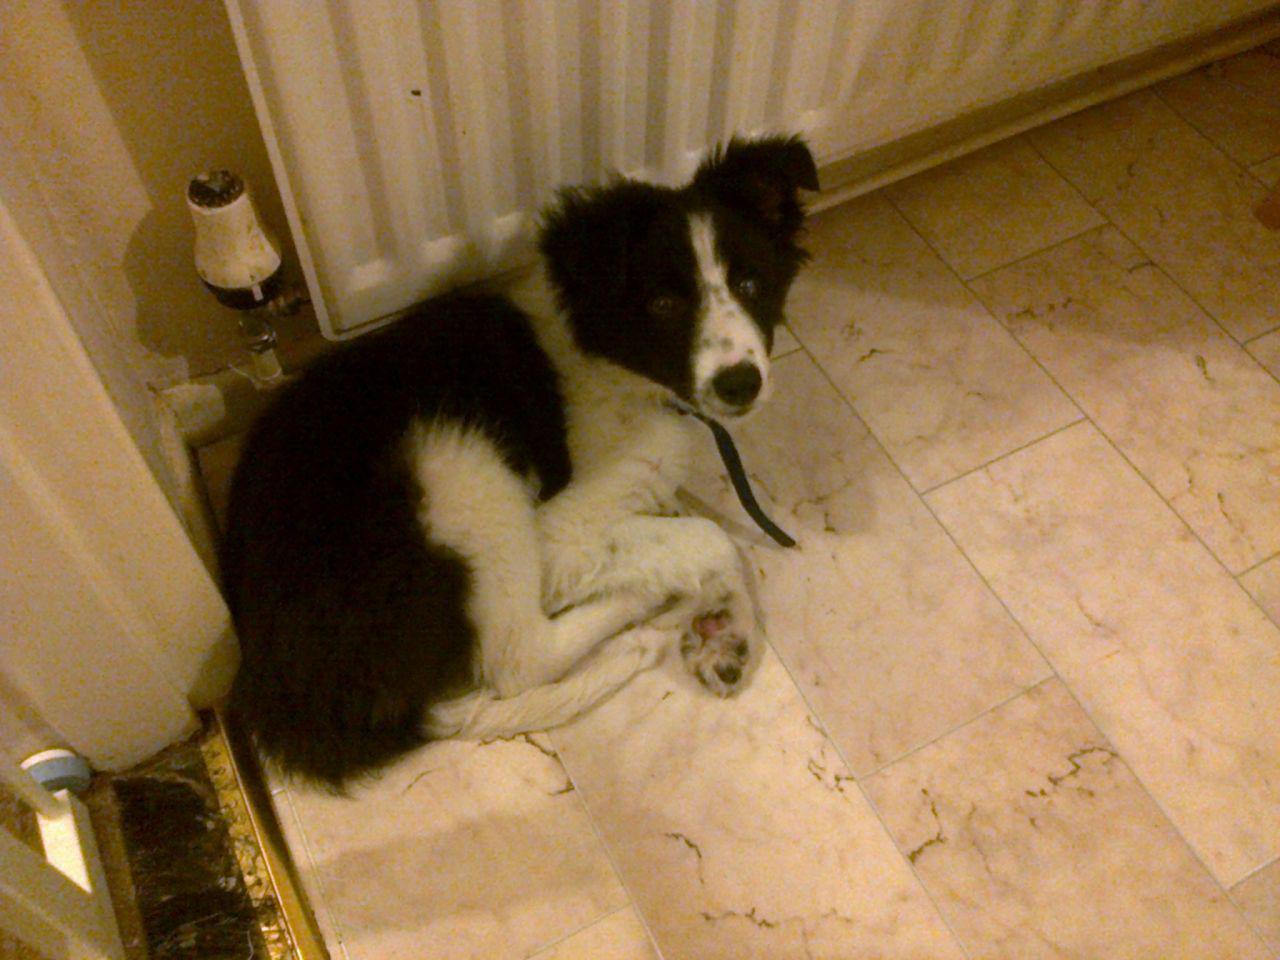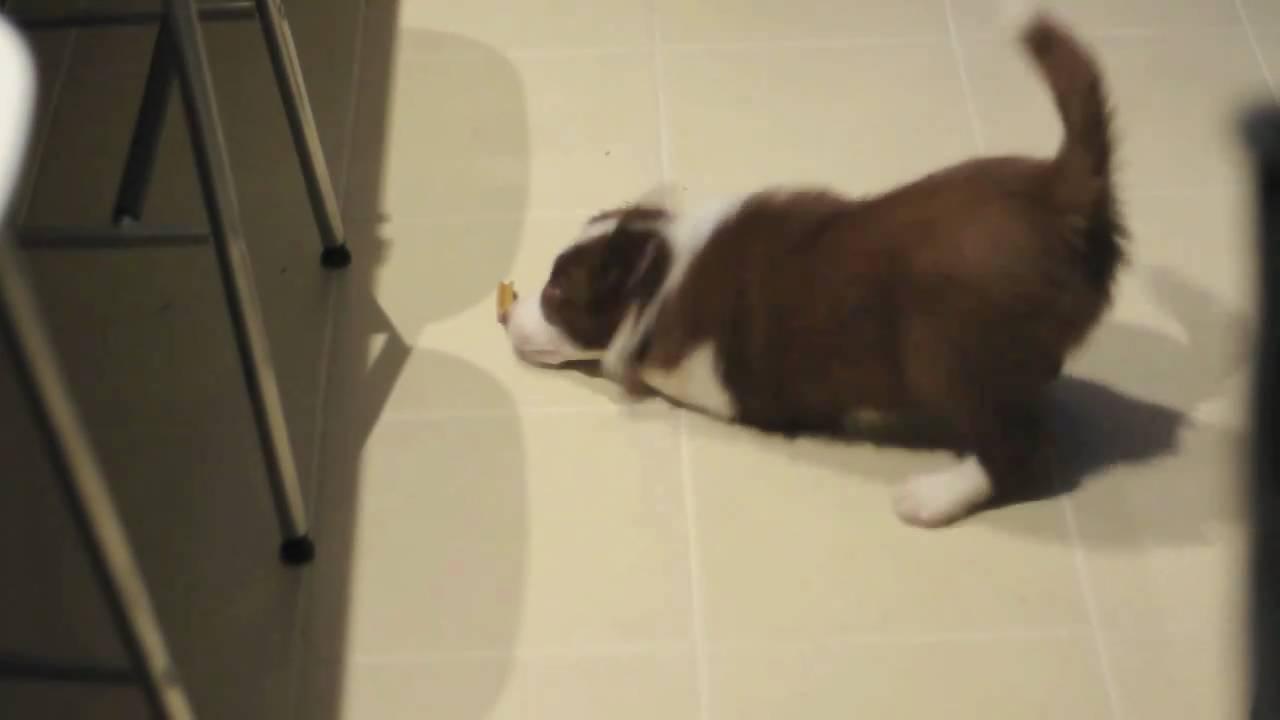The first image is the image on the left, the second image is the image on the right. Evaluate the accuracy of this statement regarding the images: "In one of the images there is a black and white dog lying on the floor.". Is it true? Answer yes or no. Yes. The first image is the image on the left, the second image is the image on the right. For the images shown, is this caption "At least one image includes a person in jeans next to a dog, and each image includes a dog that is sitting." true? Answer yes or no. No. 